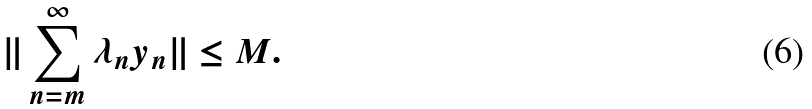Convert formula to latex. <formula><loc_0><loc_0><loc_500><loc_500>\| \sum _ { n = m } ^ { \infty } \lambda _ { n } y _ { n } \| \leq M .</formula> 